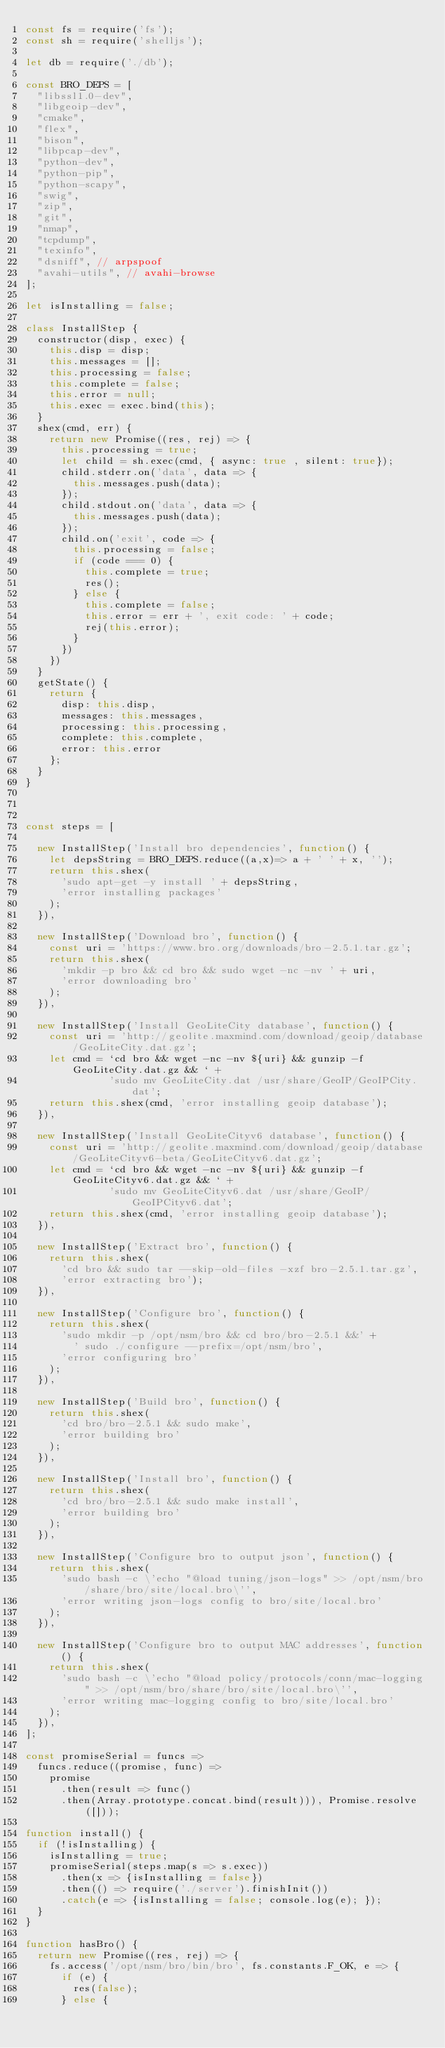Convert code to text. <code><loc_0><loc_0><loc_500><loc_500><_JavaScript_>const fs = require('fs');
const sh = require('shelljs');

let db = require('./db');

const BRO_DEPS = [
  "libssl1.0-dev",
  "libgeoip-dev",
  "cmake", 
  "flex", 
  "bison", 
  "libpcap-dev", 
  "python-dev", 
  "python-pip", 
  "python-scapy", 
  "swig", 
  "zip", 
  "git", 
  "nmap", 
  "tcpdump", 
  "texinfo",
  "dsniff", // arpspoof
  "avahi-utils", // avahi-browse
];

let isInstalling = false;

class InstallStep {
  constructor(disp, exec) {
    this.disp = disp;
    this.messages = [];
    this.processing = false;
    this.complete = false;
    this.error = null;
    this.exec = exec.bind(this);
  } 
  shex(cmd, err) {
    return new Promise((res, rej) => {
      this.processing = true;
      let child = sh.exec(cmd, { async: true , silent: true});
      child.stderr.on('data', data => {
        this.messages.push(data);
      });
      child.stdout.on('data', data => {
        this.messages.push(data);
      });
      child.on('exit', code => {
        this.processing = false;
        if (code === 0) {
          this.complete = true;
          res();
        } else {
          this.complete = false;
          this.error = err + ', exit code: ' + code;
          rej(this.error);
        }
      })
    })
  }
  getState() {
    return {
      disp: this.disp,
      messages: this.messages,
      processing: this.processing,
      complete: this.complete,
      error: this.error
    };
  }
}



const steps = [

  new InstallStep('Install bro dependencies', function() {
    let depsString = BRO_DEPS.reduce((a,x)=> a + ' ' + x, '');
    return this.shex(
      'sudo apt-get -y install ' + depsString, 
      'error installing packages'
    );
  }),

  new InstallStep('Download bro', function() {
    const uri = 'https://www.bro.org/downloads/bro-2.5.1.tar.gz';
    return this.shex(
      'mkdir -p bro && cd bro && sudo wget -nc -nv ' + uri,
      'error downloading bro'
    );
  }),

  new InstallStep('Install GeoLiteCity database', function() {
    const uri = 'http://geolite.maxmind.com/download/geoip/database/GeoLiteCity.dat.gz';
    let cmd = `cd bro && wget -nc -nv ${uri} && gunzip -f GeoLiteCity.dat.gz && ` + 
              'sudo mv GeoLiteCity.dat /usr/share/GeoIP/GeoIPCity.dat';
    return this.shex(cmd, 'error installing geoip database');
  }),

  new InstallStep('Install GeoLiteCityv6 database', function() {
    const uri = 'http://geolite.maxmind.com/download/geoip/database/GeoLiteCityv6-beta/GeoLiteCityv6.dat.gz';
    let cmd = `cd bro && wget -nc -nv ${uri} && gunzip -f GeoLiteCityv6.dat.gz && ` + 
              'sudo mv GeoLiteCityv6.dat /usr/share/GeoIP/GeoIPCityv6.dat';
    return this.shex(cmd, 'error installing geoip database');
  }),

  new InstallStep('Extract bro', function() {
    return this.shex(
      'cd bro && sudo tar --skip-old-files -xzf bro-2.5.1.tar.gz', 
      'error extracting bro');
  }),

  new InstallStep('Configure bro', function() {
    return this.shex(
      'sudo mkdir -p /opt/nsm/bro && cd bro/bro-2.5.1 &&' + 
        ' sudo ./configure --prefix=/opt/nsm/bro',
      'error configuring bro'
    );
  }),

  new InstallStep('Build bro', function() {
    return this.shex(
      'cd bro/bro-2.5.1 && sudo make',
      'error building bro'
    );
  }),

  new InstallStep('Install bro', function() {
    return this.shex(
      'cd bro/bro-2.5.1 && sudo make install',
      'error building bro'
    );
  }),

  new InstallStep('Configure bro to output json', function() {
    return this.shex(
      'sudo bash -c \'echo "@load tuning/json-logs" >> /opt/nsm/bro/share/bro/site/local.bro\'',
      'error writing json-logs config to bro/site/local.bro'
    );
  }),

  new InstallStep('Configure bro to output MAC addresses', function() {
    return this.shex(
      'sudo bash -c \'echo "@load policy/protocols/conn/mac-logging" >> /opt/nsm/bro/share/bro/site/local.bro\'',
      'error writing mac-logging config to bro/site/local.bro'
    );
  }),
];

const promiseSerial = funcs =>
  funcs.reduce((promise, func) =>
    promise
      .then(result => func()
      .then(Array.prototype.concat.bind(result))), Promise.resolve([]));

function install() {
  if (!isInstalling) {
    isInstalling = true;
    promiseSerial(steps.map(s => s.exec))
      .then(x => {isInstalling = false})
      .then(() => require('./server').finishInit())
      .catch(e => {isInstalling = false; console.log(e); });
  }
}

function hasBro() {
  return new Promise((res, rej) => {
    fs.access('/opt/nsm/bro/bin/bro', fs.constants.F_OK, e => {
      if (e) {
        res(false);
      } else {</code> 